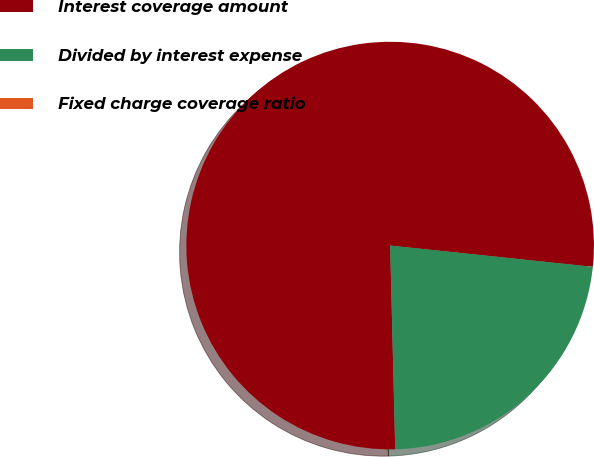Convert chart. <chart><loc_0><loc_0><loc_500><loc_500><pie_chart><fcel>Interest coverage amount<fcel>Divided by interest expense<fcel>Fixed charge coverage ratio<nl><fcel>77.06%<fcel>22.94%<fcel>0.0%<nl></chart> 